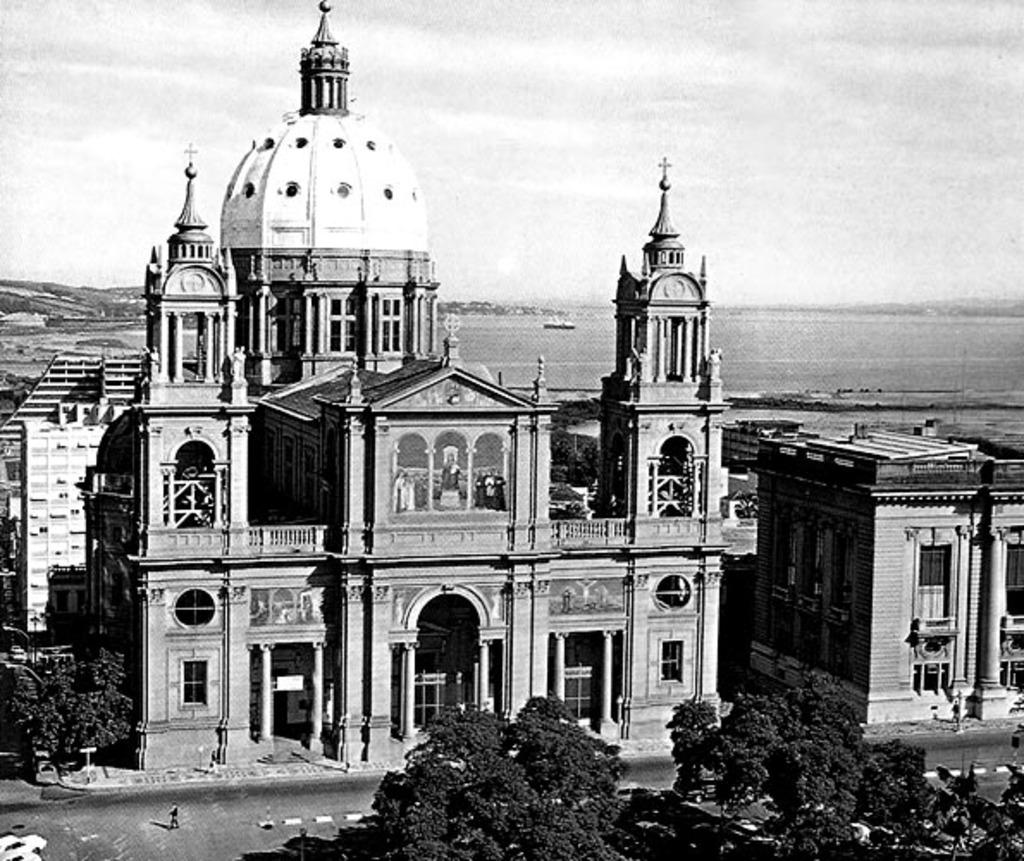What type of vegetation is at the bottom of the image? There are trees at the bottom of the image. What can be seen running through the image? There is a road in the image. What type of structures are in the middle of the image? There are buildings in the middle of the image. What type of feather can be seen floating in the air in the image? There is no feather present in the image; it only features trees, a road, and buildings. 